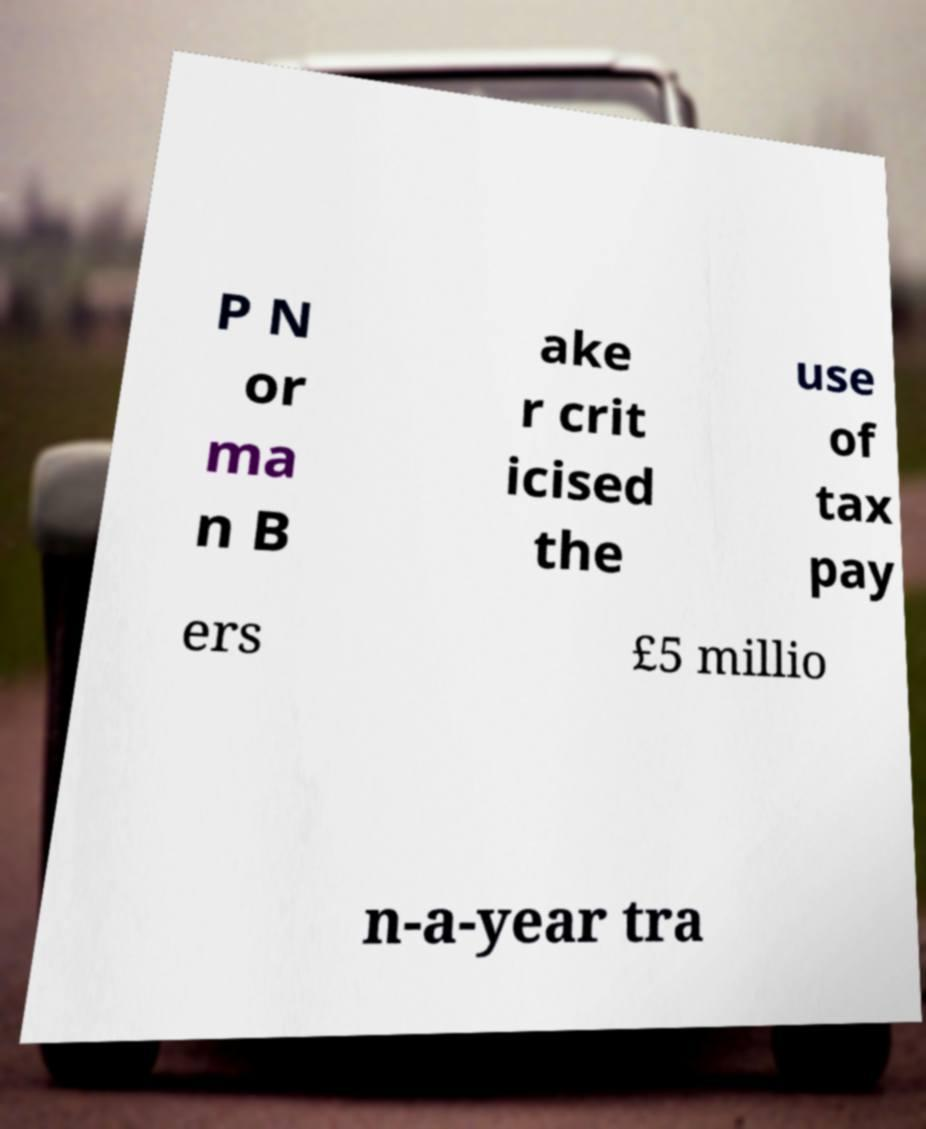Can you accurately transcribe the text from the provided image for me? P N or ma n B ake r crit icised the use of tax pay ers £5 millio n-a-year tra 